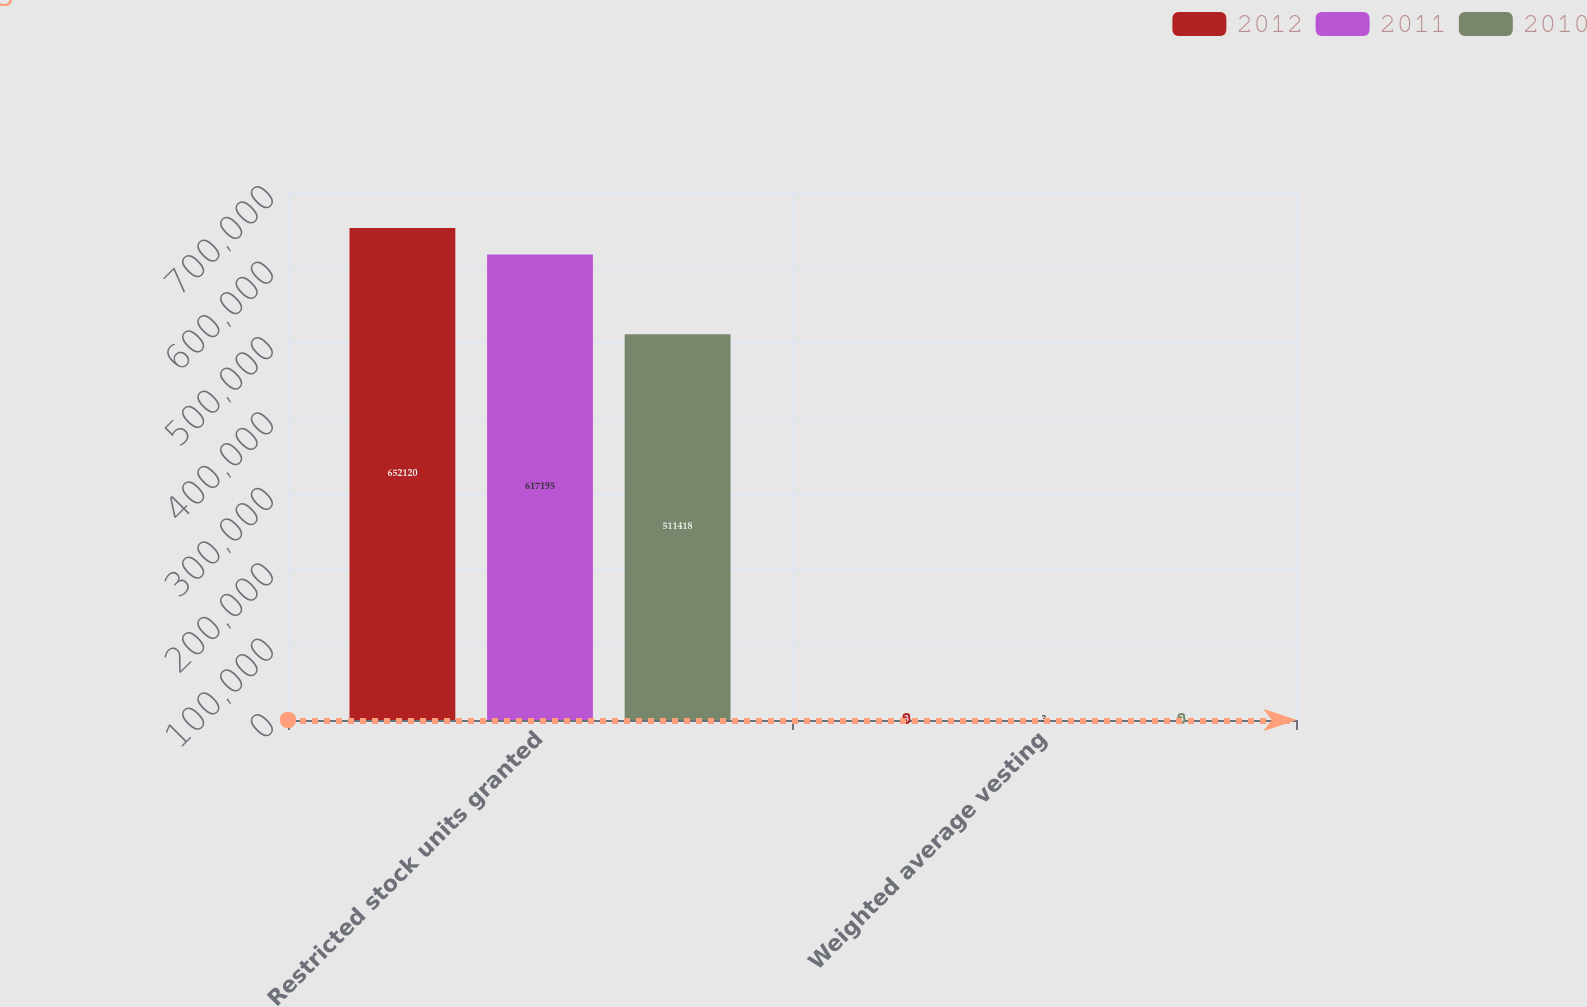<chart> <loc_0><loc_0><loc_500><loc_500><stacked_bar_chart><ecel><fcel>Restricted stock units granted<fcel>Weighted average vesting<nl><fcel>2012<fcel>652120<fcel>3<nl><fcel>2011<fcel>617195<fcel>3<nl><fcel>2010<fcel>511418<fcel>3<nl></chart> 